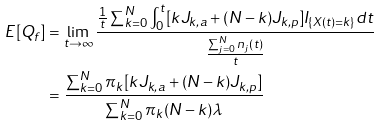<formula> <loc_0><loc_0><loc_500><loc_500>E [ Q _ { f } ] & = \lim _ { t \to \infty } \frac { \frac { 1 } { t } \sum _ { k = 0 } ^ { N } \int _ { 0 } ^ { t } [ k J _ { k , a } + ( N - k ) J _ { k , p } ] I _ { \{ X ( t ) = k \} } d t } { \frac { \sum _ { j = 0 } ^ { N } n _ { j } ( t ) } { t } } \\ & = \frac { \sum _ { k = 0 } ^ { N } \pi _ { k } [ k J _ { k , a } + ( N - k ) J _ { k , p } ] } { \sum _ { k = 0 } ^ { N } \pi _ { k } ( N - k ) \lambda } \\</formula> 